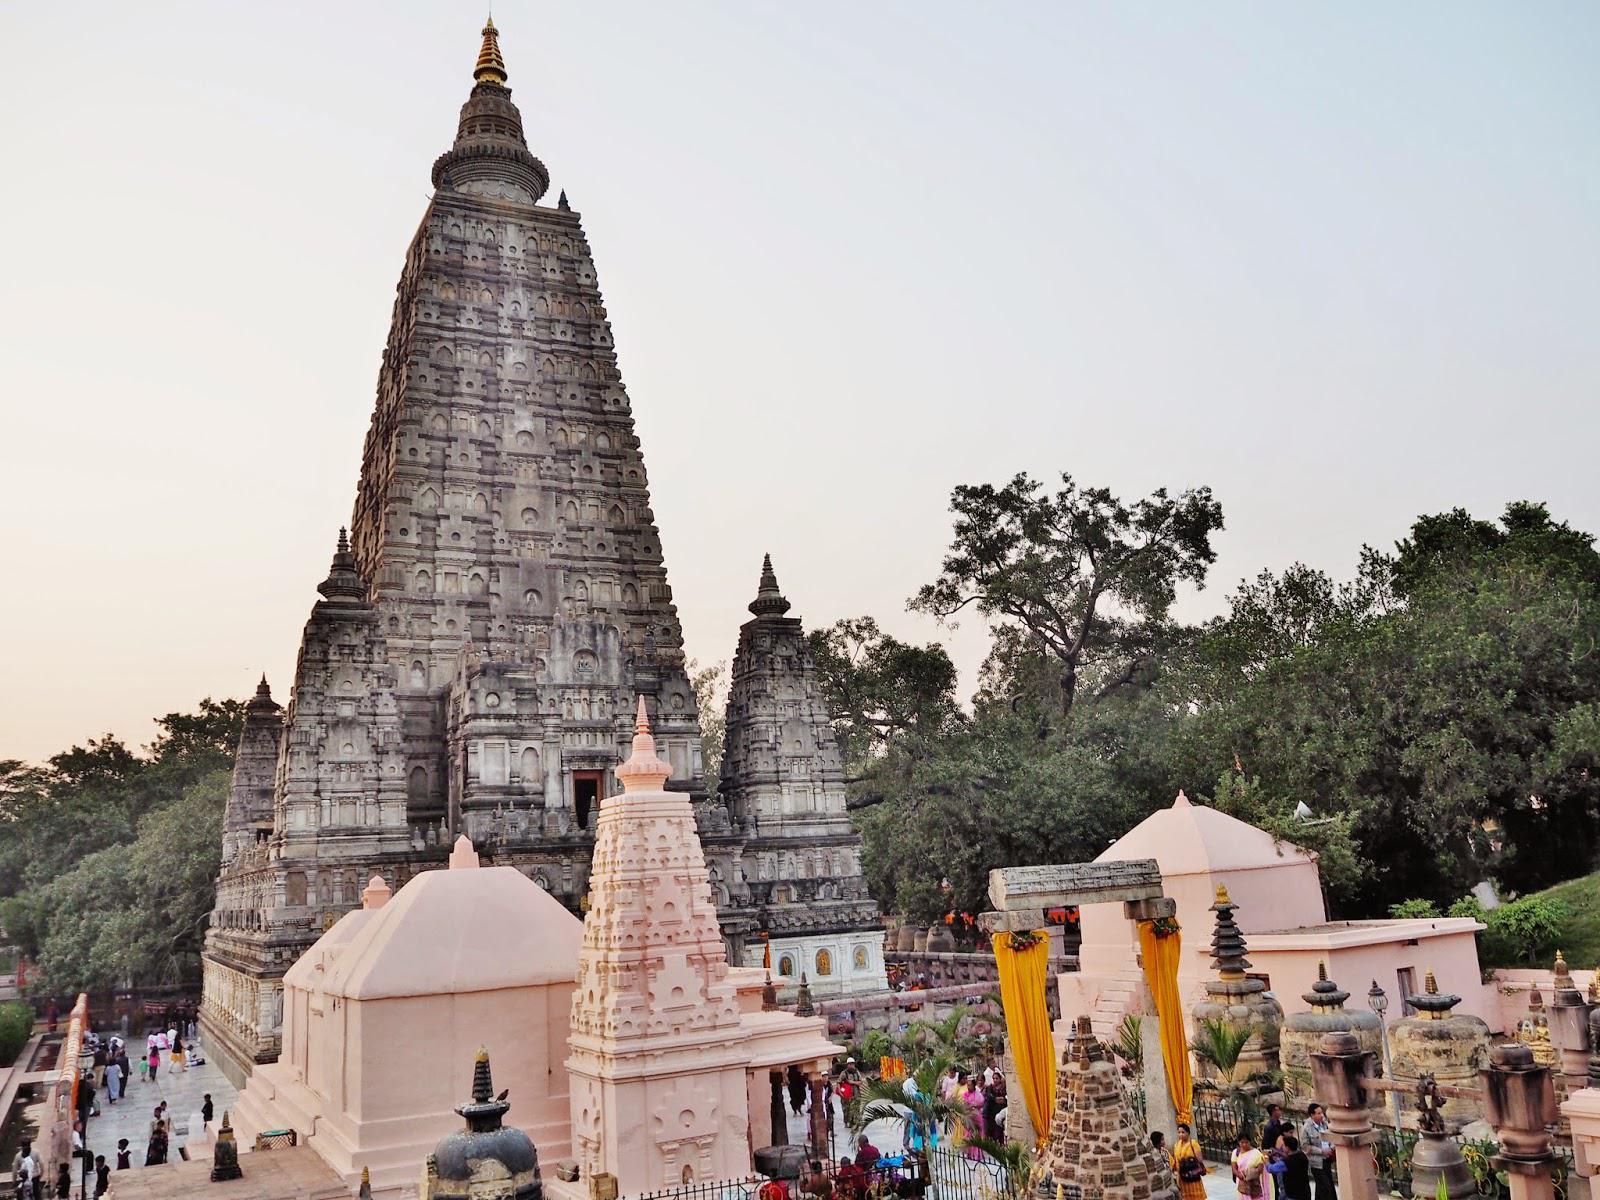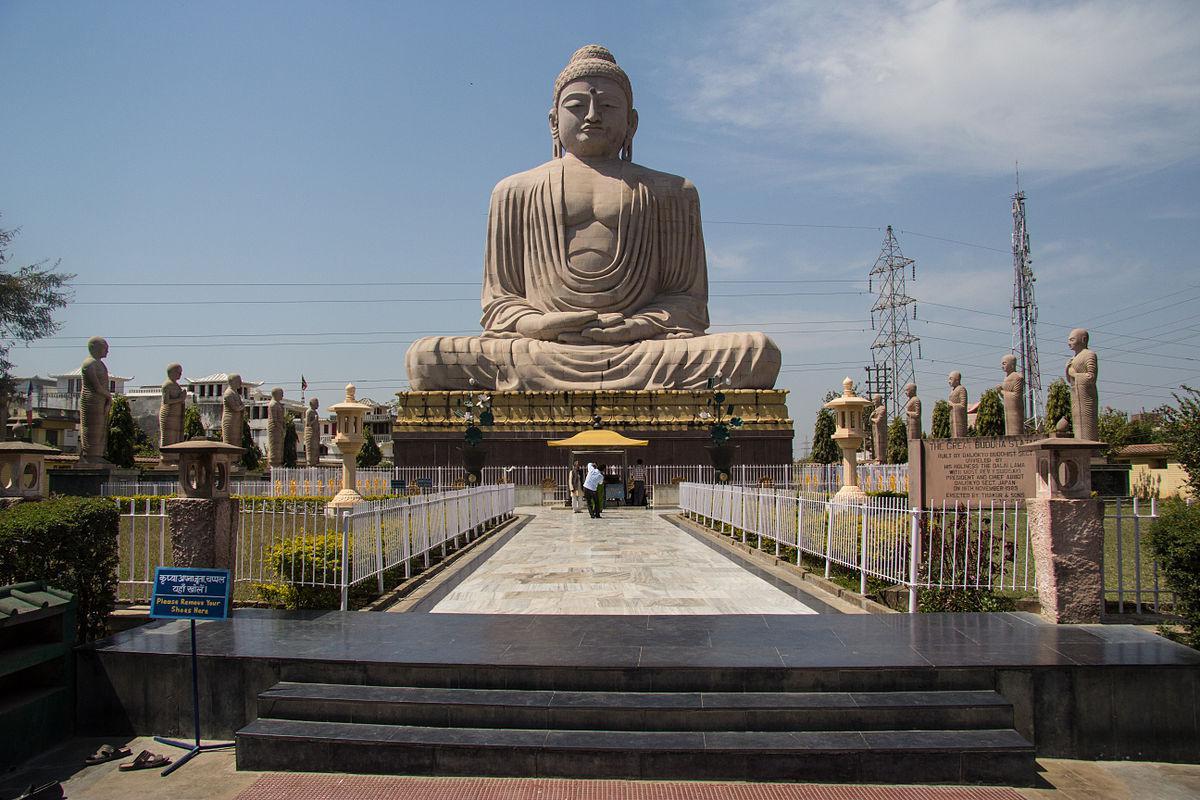The first image is the image on the left, the second image is the image on the right. Evaluate the accuracy of this statement regarding the images: "At least one flag is waving at the site of one building.". Is it true? Answer yes or no. No. 